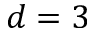Convert formula to latex. <formula><loc_0><loc_0><loc_500><loc_500>d = 3</formula> 